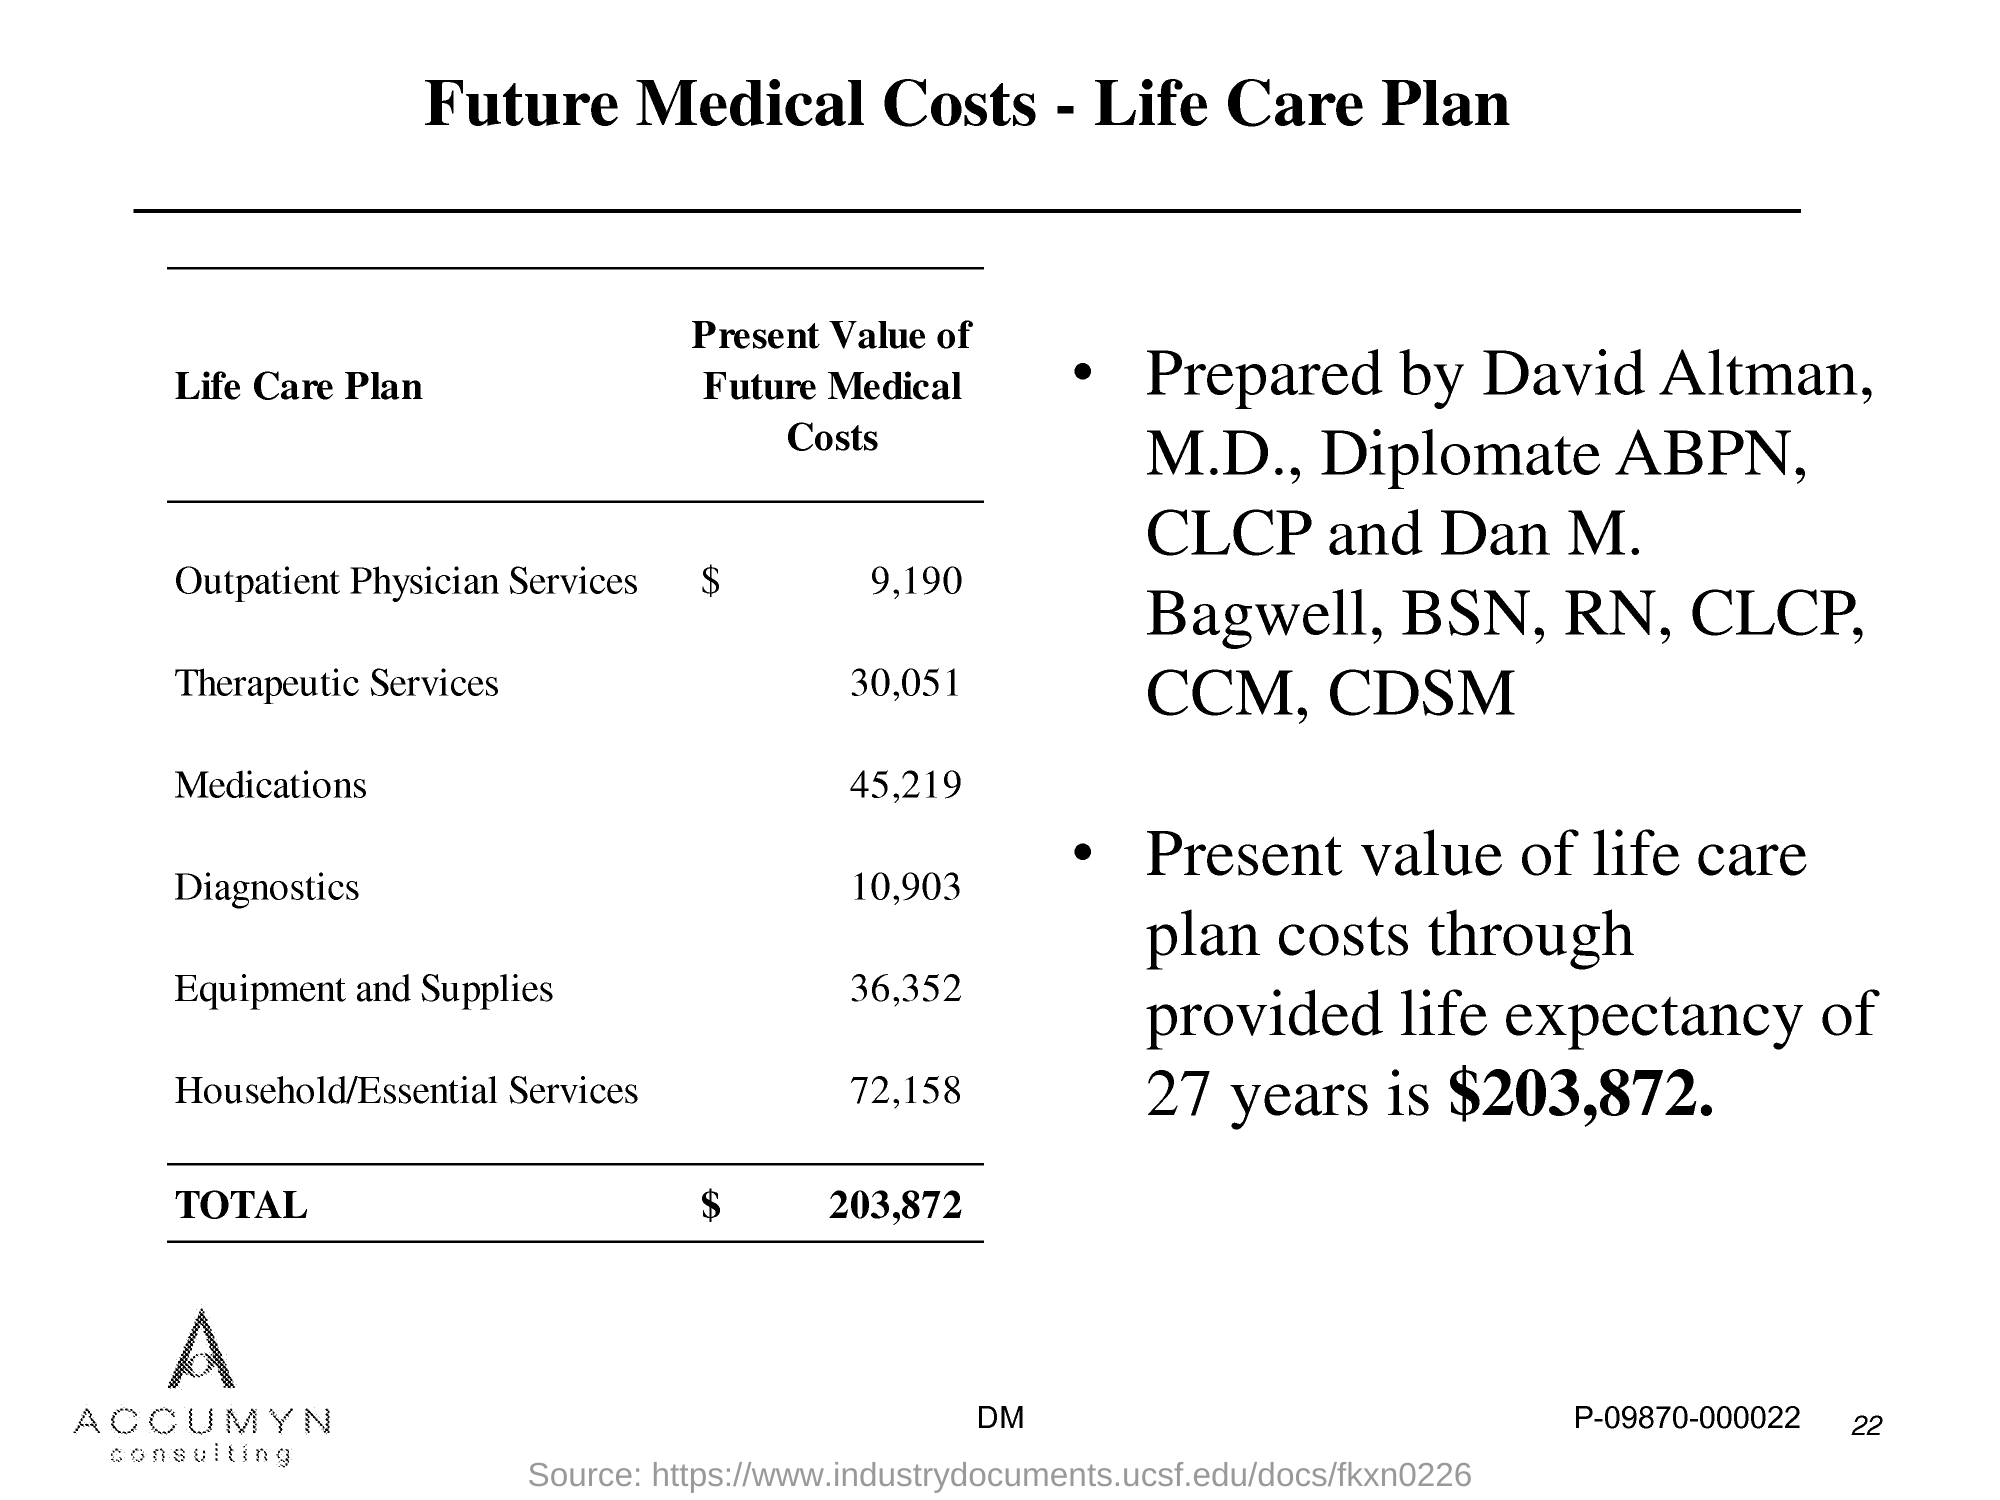Highlight a few significant elements in this photo. The title of this document is 'Future Medical Costs - Life Care Plan.' 